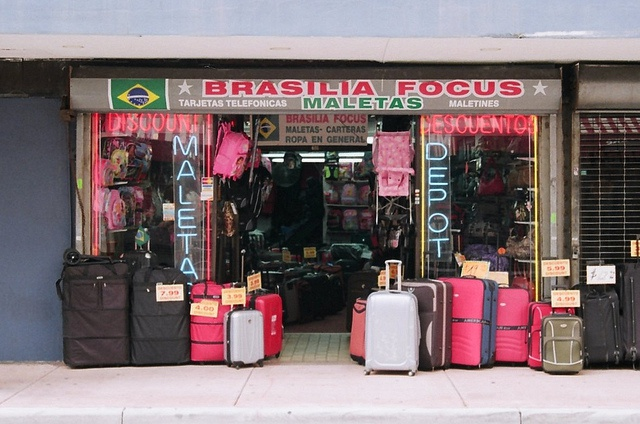Describe the objects in this image and their specific colors. I can see suitcase in lavender, black, and lightgray tones, suitcase in lavender, lightgray, darkgray, black, and gray tones, suitcase in lavender, salmon, gray, and brown tones, suitcase in lavender, maroon, brown, black, and pink tones, and suitcase in lavender, black, and gray tones in this image. 